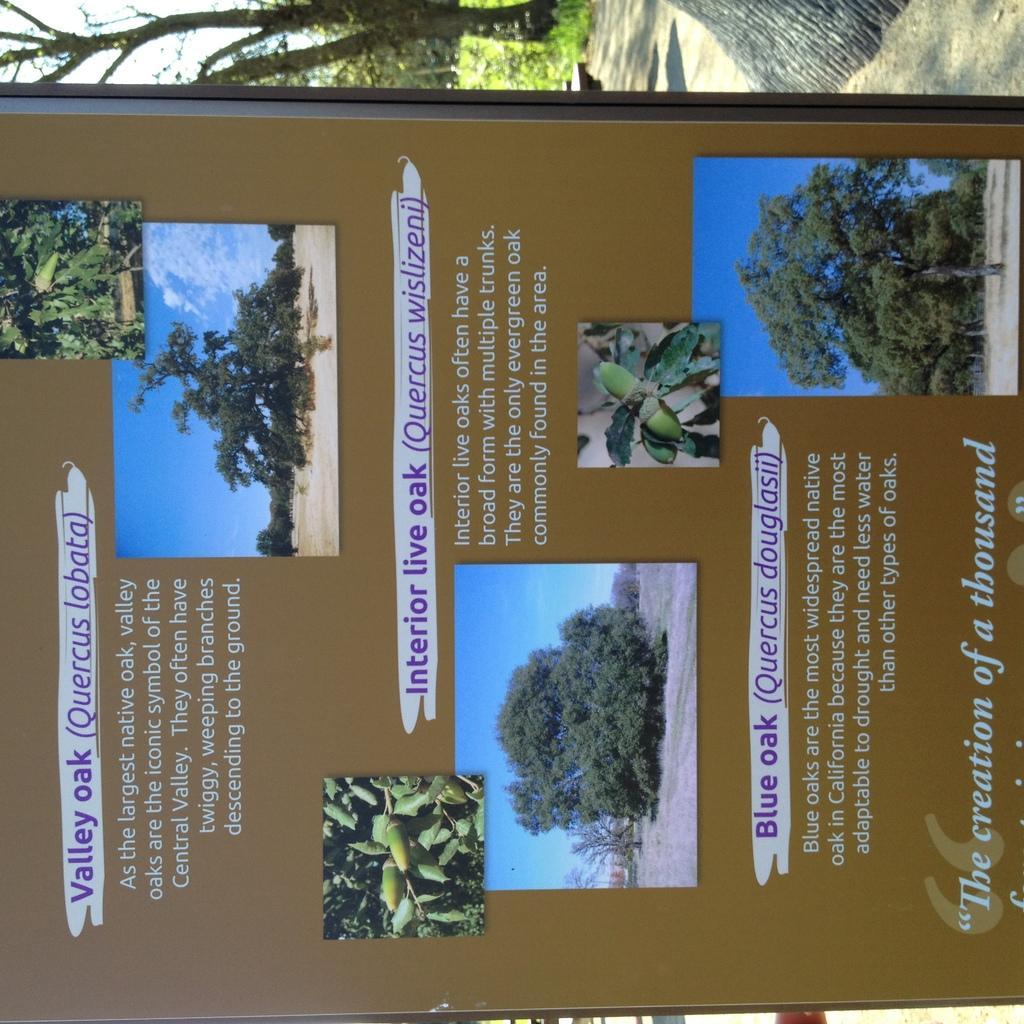Describe this image in one or two sentences. In this image, we can see a poster, on that poster there are some pictures of the trees, in the background we can see some trees. 